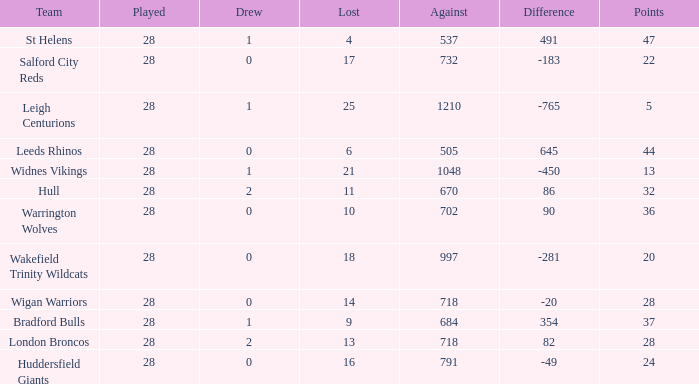Write the full table. {'header': ['Team', 'Played', 'Drew', 'Lost', 'Against', 'Difference', 'Points'], 'rows': [['St Helens', '28', '1', '4', '537', '491', '47'], ['Salford City Reds', '28', '0', '17', '732', '-183', '22'], ['Leigh Centurions', '28', '1', '25', '1210', '-765', '5'], ['Leeds Rhinos', '28', '0', '6', '505', '645', '44'], ['Widnes Vikings', '28', '1', '21', '1048', '-450', '13'], ['Hull', '28', '2', '11', '670', '86', '32'], ['Warrington Wolves', '28', '0', '10', '702', '90', '36'], ['Wakefield Trinity Wildcats', '28', '0', '18', '997', '-281', '20'], ['Wigan Warriors', '28', '0', '14', '718', '-20', '28'], ['Bradford Bulls', '28', '1', '9', '684', '354', '37'], ['London Broncos', '28', '2', '13', '718', '82', '28'], ['Huddersfield Giants', '28', '0', '16', '791', '-49', '24']]} What is the most lost games for the team with a difference smaller than 86 and points of 32? None. 